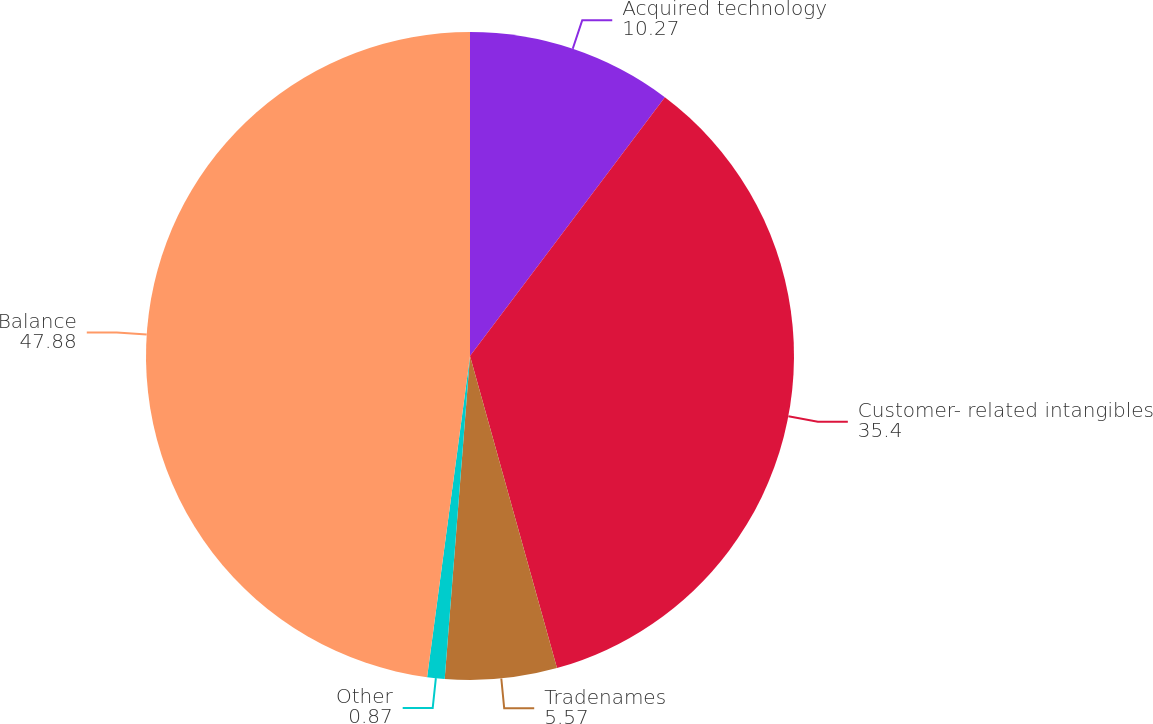Convert chart. <chart><loc_0><loc_0><loc_500><loc_500><pie_chart><fcel>Acquired technology<fcel>Customer- related intangibles<fcel>Tradenames<fcel>Other<fcel>Balance<nl><fcel>10.27%<fcel>35.4%<fcel>5.57%<fcel>0.87%<fcel>47.88%<nl></chart> 